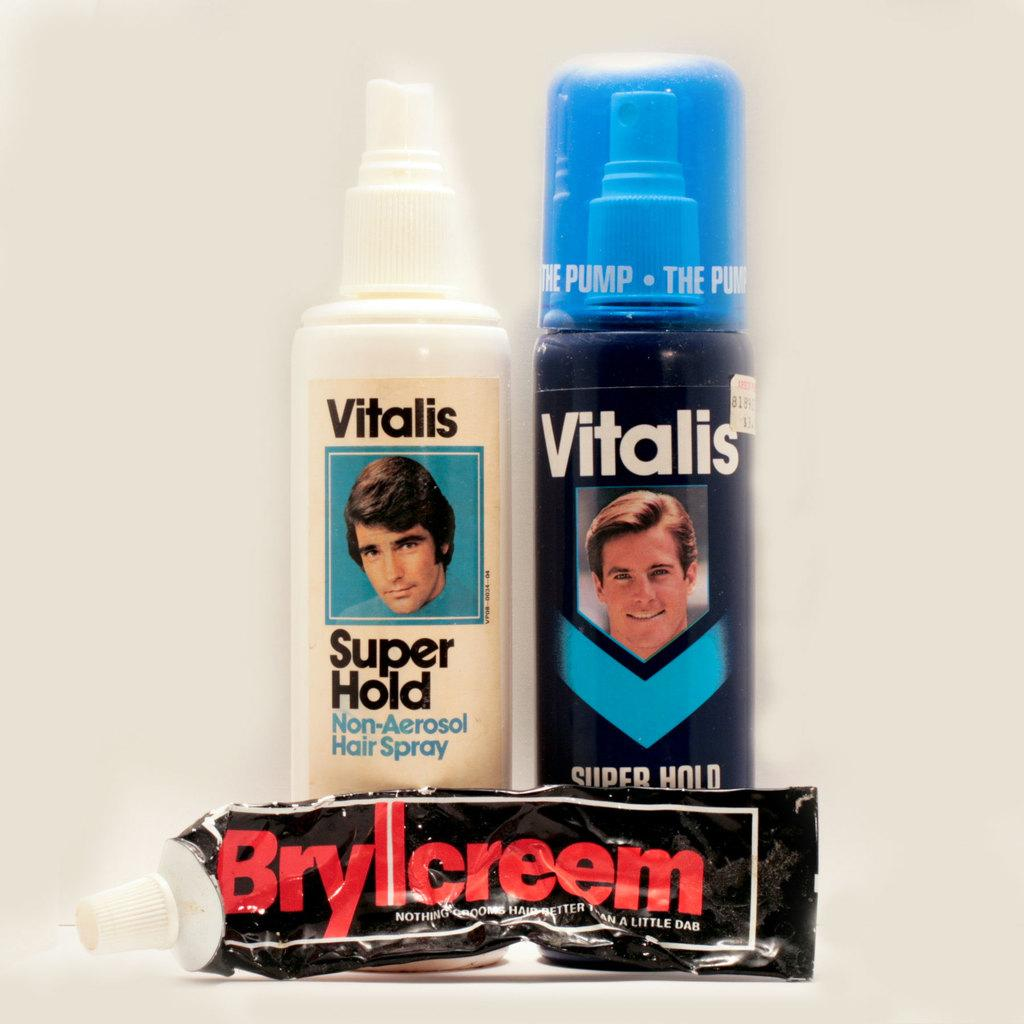Provide a one-sentence caption for the provided image. A group of three hair products, two of which are Vitalis brand. 